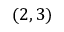<formula> <loc_0><loc_0><loc_500><loc_500>( 2 , 3 )</formula> 